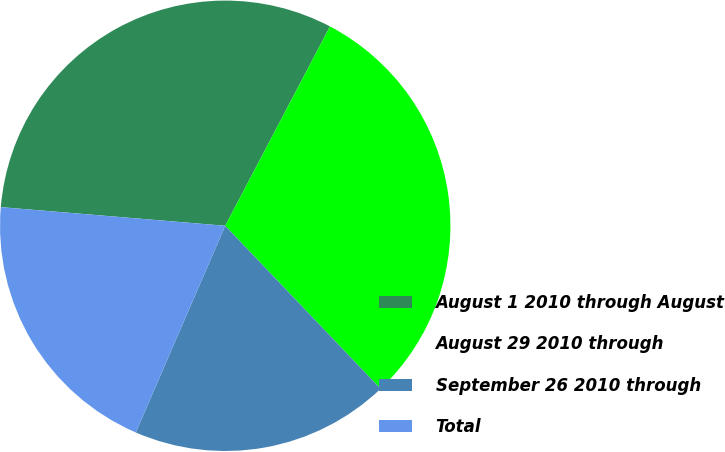Convert chart. <chart><loc_0><loc_0><loc_500><loc_500><pie_chart><fcel>August 1 2010 through August<fcel>August 29 2010 through<fcel>September 26 2010 through<fcel>Total<nl><fcel>31.38%<fcel>30.18%<fcel>18.62%<fcel>19.82%<nl></chart> 